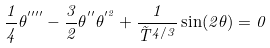Convert formula to latex. <formula><loc_0><loc_0><loc_500><loc_500>\frac { 1 } { 4 } \theta ^ { ^ { \prime \prime \prime \prime } } - \frac { 3 } { 2 } \theta ^ { ^ { \prime \prime } } \theta ^ { ^ { \prime 2 } } + \frac { 1 } { \tilde { T } ^ { 4 / 3 } } \sin ( 2 \theta ) = 0</formula> 